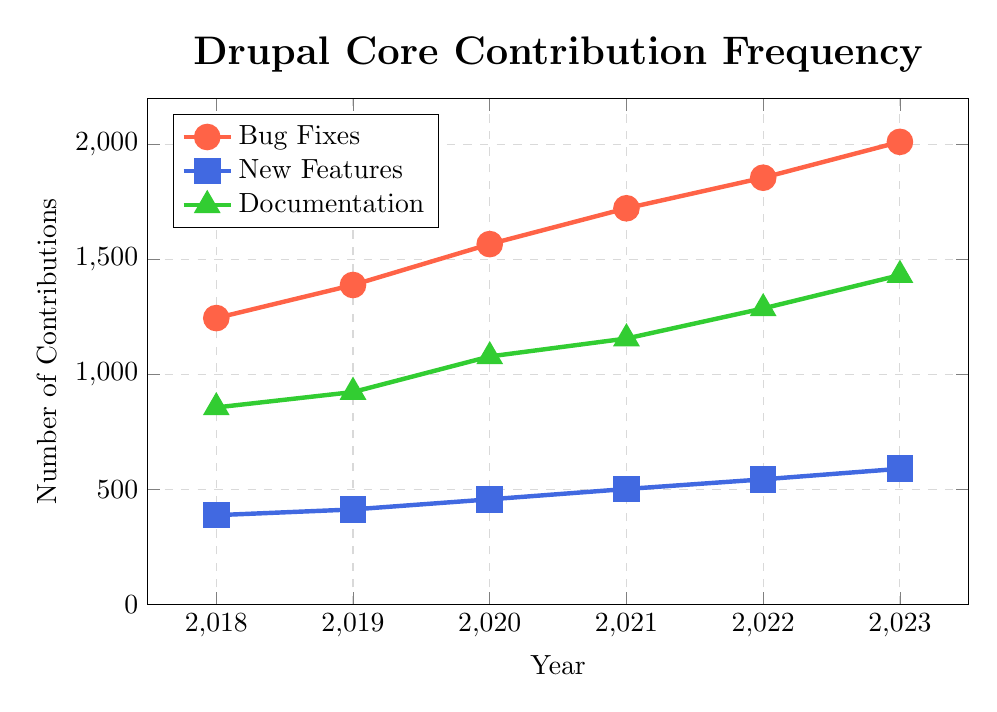what is the trend of bug fixes from 2018 to 2023? To identify the trend, observe the line marked with circles (red color) representing bug fixes. This line shows a steady increase in contributions every year from 2018 to 2023.
Answer: Increasing In which year did new features have the highest number of contributions? Look at the blue line with square markers representing new features. The highest point is in 2023 with 589 contributions.
Answer: 2023 How many total contributions were made for documentation between 2018 and 2020? Add the contributions from the green line with triangle markers for the years 2018 to 2020: 856 (2018) + 923 (2019) + 1078 (2020) = 2857.
Answer: 2857 What is the difference in the number of bug fixes between 2018 and 2023? Calculate the difference by subtracting the number of bug fixes in 2018 from the number in 2023: 2012 (2023) - 1245 (2018) = 767.
Answer: 767 Which type of contribution had the highest growth rate between 2018 and 2023? Calculate the growth rate for each type by comparing the 2023 value to the 2018 value. Bug fixes: (2012/1245) - 1, new features: (589/387) - 1, documentation: (1432/856) - 1. Documentation has the highest growth rate.
Answer: Documentation What is the average number of new features added per year from 2019 to 2023? Sum the contributions for new features from 2019 to 2023 and divide by 5: (412 + 456 + 501 + 543 + 589) / 5 = 500.2.
Answer: 500.2 How does the number of documentation contributions in 2020 compare to bug fixes in the same year? Compare the values from the green line with triangle markers (Documentation) and red line with circle markers (Bug Fixes) for 2020. Documentation: 1078, Bug Fixes: 1567. 1567 is greater than 1078.
Answer: Bug Fixes are higher Which type of contribution shows the least variation over the years? Visually inspect the three lines and note that the blue line (new features) appears to have the least steep slope and thus the least dramatic change.
Answer: New Features In what year did the combined contributions of bug fixes and new features first exceed 2000? Sum the contributions of bug fixes and new features for each year until the sum exceeds 2000. For 2020: 1567 (Bug Fixes) + 456 (New Features) = 2023, which exceeds 2000 for the first time.
Answer: 2020 